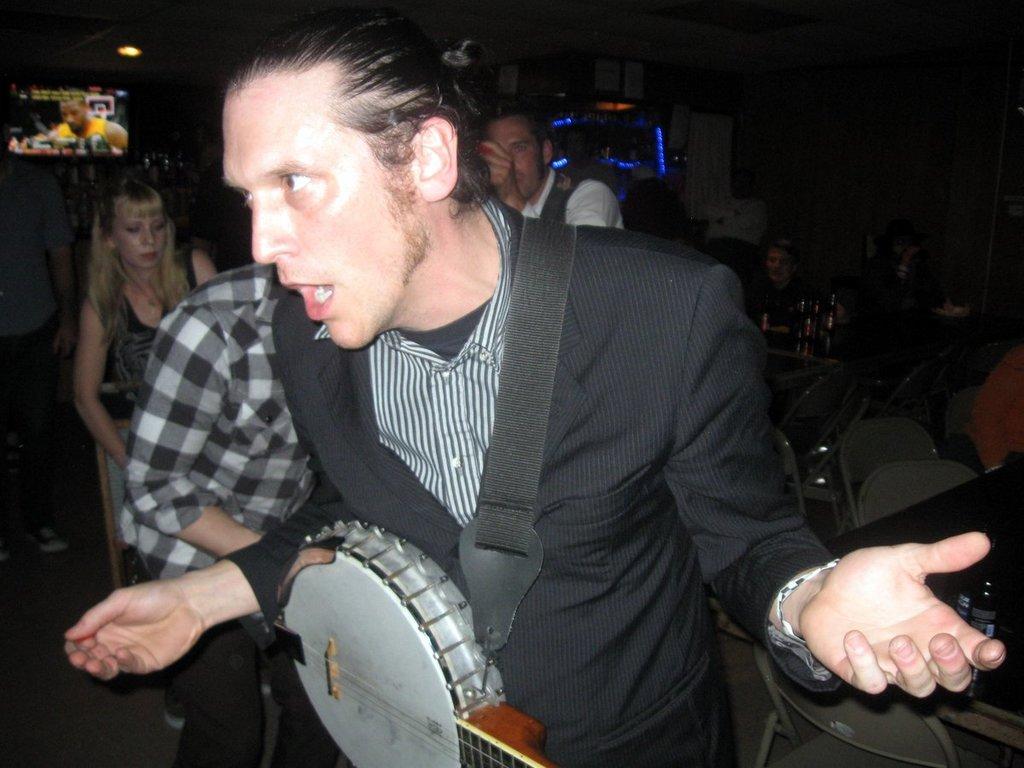Can you describe this image briefly? In this picture there is a person wearing black suit is carrying a guitar and there are few other persons behind him and there are few tables and chairs in the right corner and there is a television in the left top corner. 